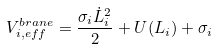Convert formula to latex. <formula><loc_0><loc_0><loc_500><loc_500>V ^ { b r a n e } _ { i , e f f } = \frac { \sigma _ { i } \dot { L } ^ { 2 } _ { i } } { 2 } + U ( L _ { i } ) + \sigma _ { i }</formula> 